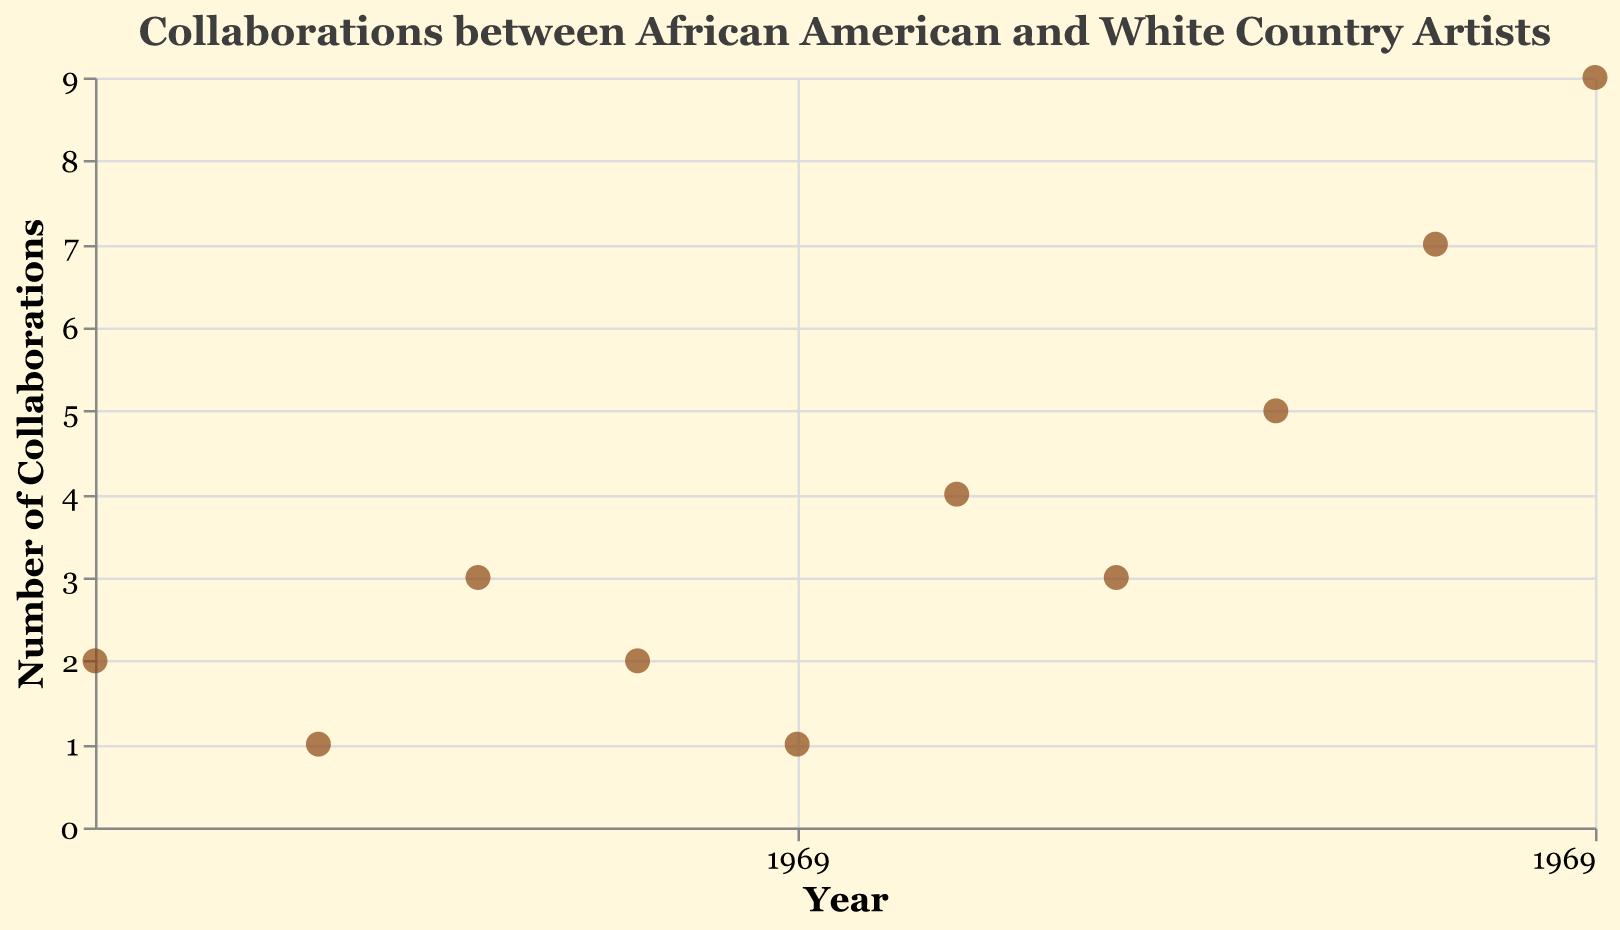what is the title of the plot? The title of the plot is located at the top center of the figure and gives a summary of the data being presented. In this case, the title summarizing the figure is "Collaborations between African American and White Country Artists."
Answer: "Collaborations between African American and White Country Artists" How many total collaborations are shown in the year 2020? By looking at the data point representing the year 2020 and reading the y-axis value corresponding to that point, you can see that there are 9 collaborations indicated.
Answer: 9 Which artist had the highest number of collaborations over the past 50 years? To find this, locate the data point with the highest y-axis value. The tooltip shows the artist's name, which is "Jimmie Allen" with 9 collaborations in the year 2020.
Answer: Jimmie Allen How many total data points are present in the figure? Count the number of different data points shown in the plot. Each data point represents an artist-year-collaboration entry. From the figure, you will see there are 10 points in total.
Answer: 10 What is the range of years shown on the x-axis? The x-axis represents the timeline, and by looking at the start and end points of the axis, you will see it ranges from 1973 to 2020.
Answer: 1973 to 2020 How many artists had more than 4 collaborations? Look at the y-axis and count the data points that have a value greater than 4 on the y-scale. There are three such points corresponding to the artists "Mickey Guyton," "Kane Brown," and "Jimmie Allen."
Answer: 3 What is the average number of collaborations in the decade of the 2000s (2000-2010)? To calculate this, take the sum of the collaborations in the years 2000, 2005, and 2010 (4 + 3 + 5 = 12) and divide by the number of data points in that range (3).
Answer: (4+3+5)/3 = 4 Compare collaborations in 1973 and 1990. Which year had more collaborations and by how many? Check the y-axis values for the years 1973 (2 collaborations) and 1990 (2 collaborations). The number of collaborations is the same in both years, so the difference is zero.
Answer: Same, difference is 0 Based on the plot, during which period (1973-1995) or (2007-2020) were there more collaborations? First sum the collaborations from 1973, 1980, 1985, 1990, and 1995 (2+1+3+2+1 = 9). Then, sum the collaborations from 2007, 2010, 2015, and 2020 (3+5+7+9 = 24). Clearly, the period 2007-2020 had more collaborations.
Answer: 2007-2020, 24 collaborations How has the collaboration trend changed over the past 50 years? Observing the figure, you see a general upward trend in the number of collaborations, with a few fluctuations. Specifically, collaborations increased significantly after 2000.
Answer: Upward trend over time 